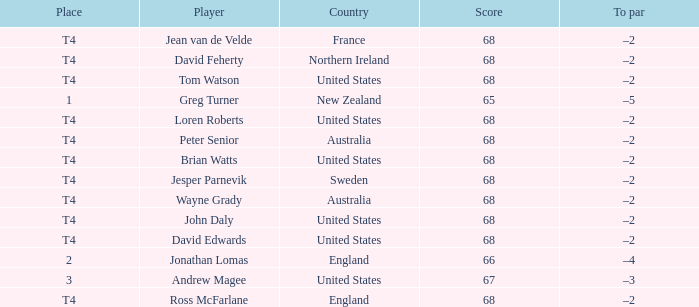Who has a To par of –2, and a Country of united states? John Daly, David Edwards, Loren Roberts, Tom Watson, Brian Watts. I'm looking to parse the entire table for insights. Could you assist me with that? {'header': ['Place', 'Player', 'Country', 'Score', 'To par'], 'rows': [['T4', 'Jean van de Velde', 'France', '68', '–2'], ['T4', 'David Feherty', 'Northern Ireland', '68', '–2'], ['T4', 'Tom Watson', 'United States', '68', '–2'], ['1', 'Greg Turner', 'New Zealand', '65', '–5'], ['T4', 'Loren Roberts', 'United States', '68', '–2'], ['T4', 'Peter Senior', 'Australia', '68', '–2'], ['T4', 'Brian Watts', 'United States', '68', '–2'], ['T4', 'Jesper Parnevik', 'Sweden', '68', '–2'], ['T4', 'Wayne Grady', 'Australia', '68', '–2'], ['T4', 'John Daly', 'United States', '68', '–2'], ['T4', 'David Edwards', 'United States', '68', '–2'], ['2', 'Jonathan Lomas', 'England', '66', '–4'], ['3', 'Andrew Magee', 'United States', '67', '–3'], ['T4', 'Ross McFarlane', 'England', '68', '–2']]} 